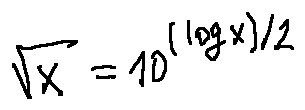<formula> <loc_0><loc_0><loc_500><loc_500>\sqrt { x } = 1 0 ^ { ( \log x ) / 2 }</formula> 